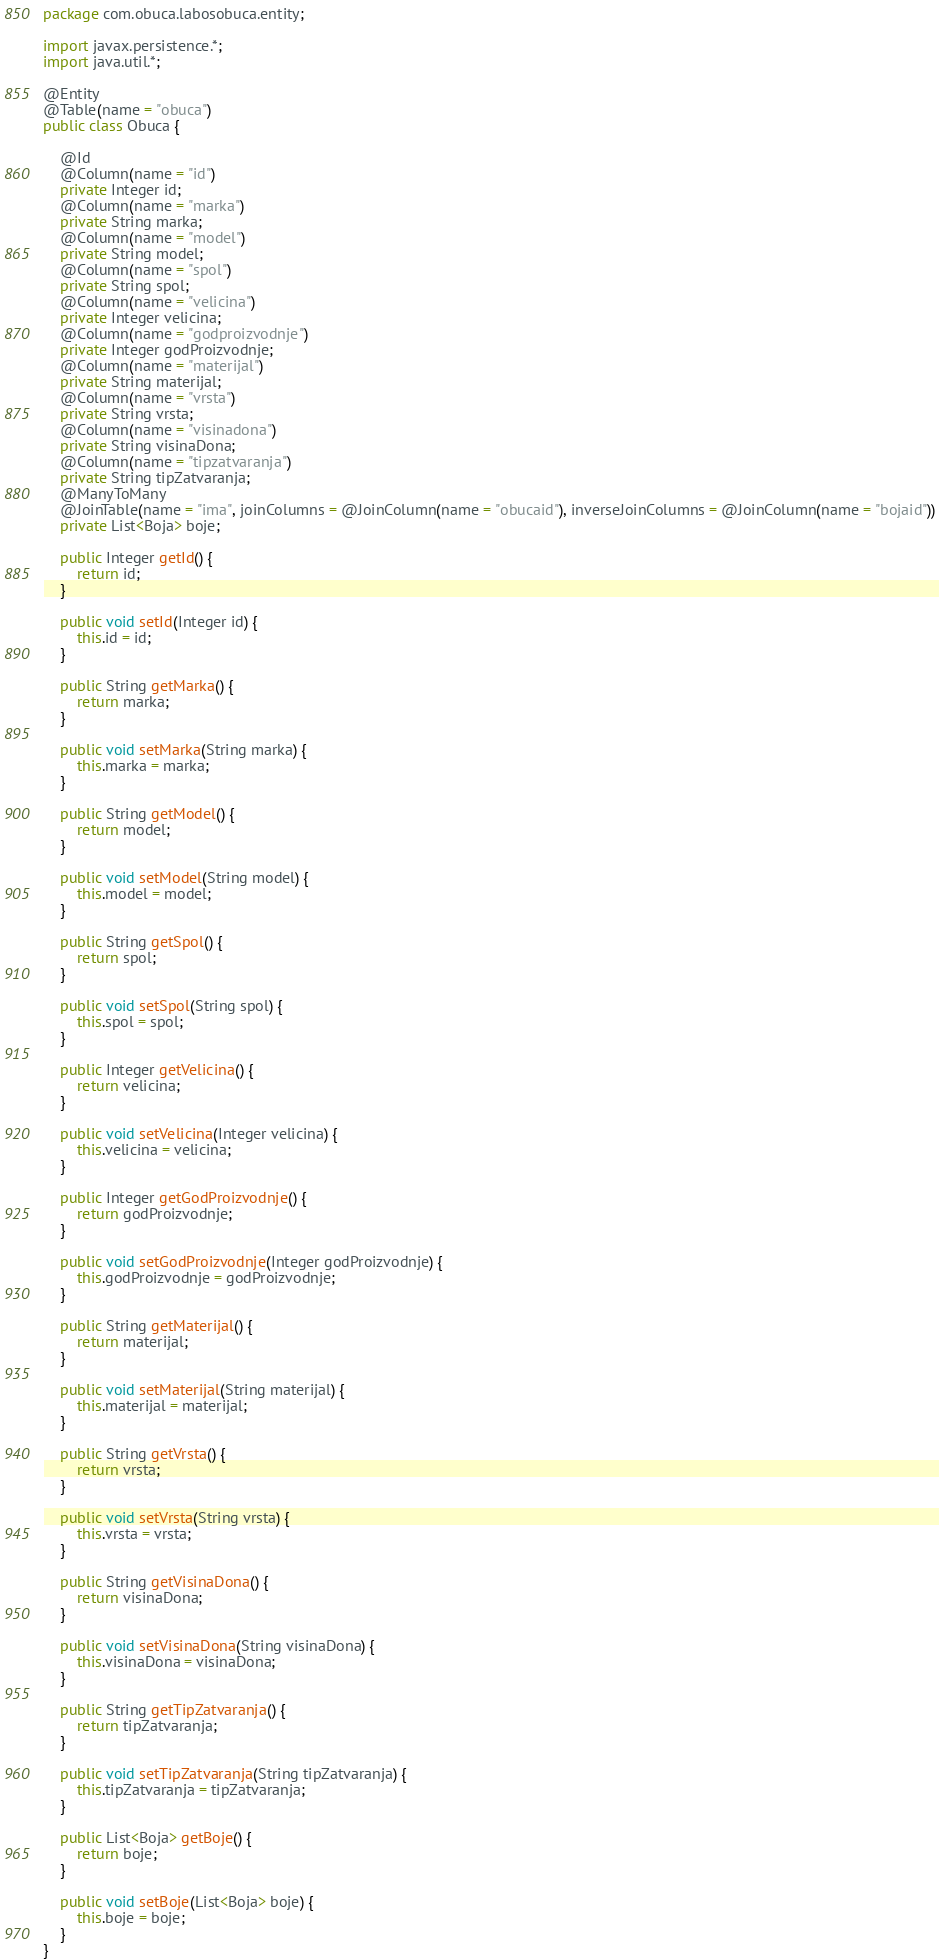Convert code to text. <code><loc_0><loc_0><loc_500><loc_500><_Java_>package com.obuca.labosobuca.entity;

import javax.persistence.*;
import java.util.*;

@Entity
@Table(name = "obuca")
public class Obuca {

    @Id
    @Column(name = "id")
    private Integer id;
    @Column(name = "marka")
    private String marka;
    @Column(name = "model")
    private String model;
    @Column(name = "spol")
    private String spol;
    @Column(name = "velicina")
    private Integer velicina;
    @Column(name = "godproizvodnje")
    private Integer godProizvodnje;
    @Column(name = "materijal")
    private String materijal;
    @Column(name = "vrsta")
    private String vrsta;
    @Column(name = "visinadona")
    private String visinaDona;
    @Column(name = "tipzatvaranja")
    private String tipZatvaranja;
    @ManyToMany
    @JoinTable(name = "ima", joinColumns = @JoinColumn(name = "obucaid"), inverseJoinColumns = @JoinColumn(name = "bojaid"))
    private List<Boja> boje;

    public Integer getId() {
        return id;
    }

    public void setId(Integer id) {
        this.id = id;
    }

    public String getMarka() {
        return marka;
    }

    public void setMarka(String marka) {
        this.marka = marka;
    }

    public String getModel() {
        return model;
    }

    public void setModel(String model) {
        this.model = model;
    }

    public String getSpol() {
        return spol;
    }

    public void setSpol(String spol) {
        this.spol = spol;
    }

    public Integer getVelicina() {
        return velicina;
    }

    public void setVelicina(Integer velicina) {
        this.velicina = velicina;
    }

    public Integer getGodProizvodnje() {
        return godProizvodnje;
    }

    public void setGodProizvodnje(Integer godProizvodnje) {
        this.godProizvodnje = godProizvodnje;
    }

    public String getMaterijal() {
        return materijal;
    }

    public void setMaterijal(String materijal) {
        this.materijal = materijal;
    }

    public String getVrsta() {
        return vrsta;
    }

    public void setVrsta(String vrsta) {
        this.vrsta = vrsta;
    }

    public String getVisinaDona() {
        return visinaDona;
    }

    public void setVisinaDona(String visinaDona) {
        this.visinaDona = visinaDona;
    }

    public String getTipZatvaranja() {
        return tipZatvaranja;
    }

    public void setTipZatvaranja(String tipZatvaranja) {
        this.tipZatvaranja = tipZatvaranja;
    }

    public List<Boja> getBoje() {
        return boje;
    }

    public void setBoje(List<Boja> boje) {
        this.boje = boje;
    }
}
</code> 